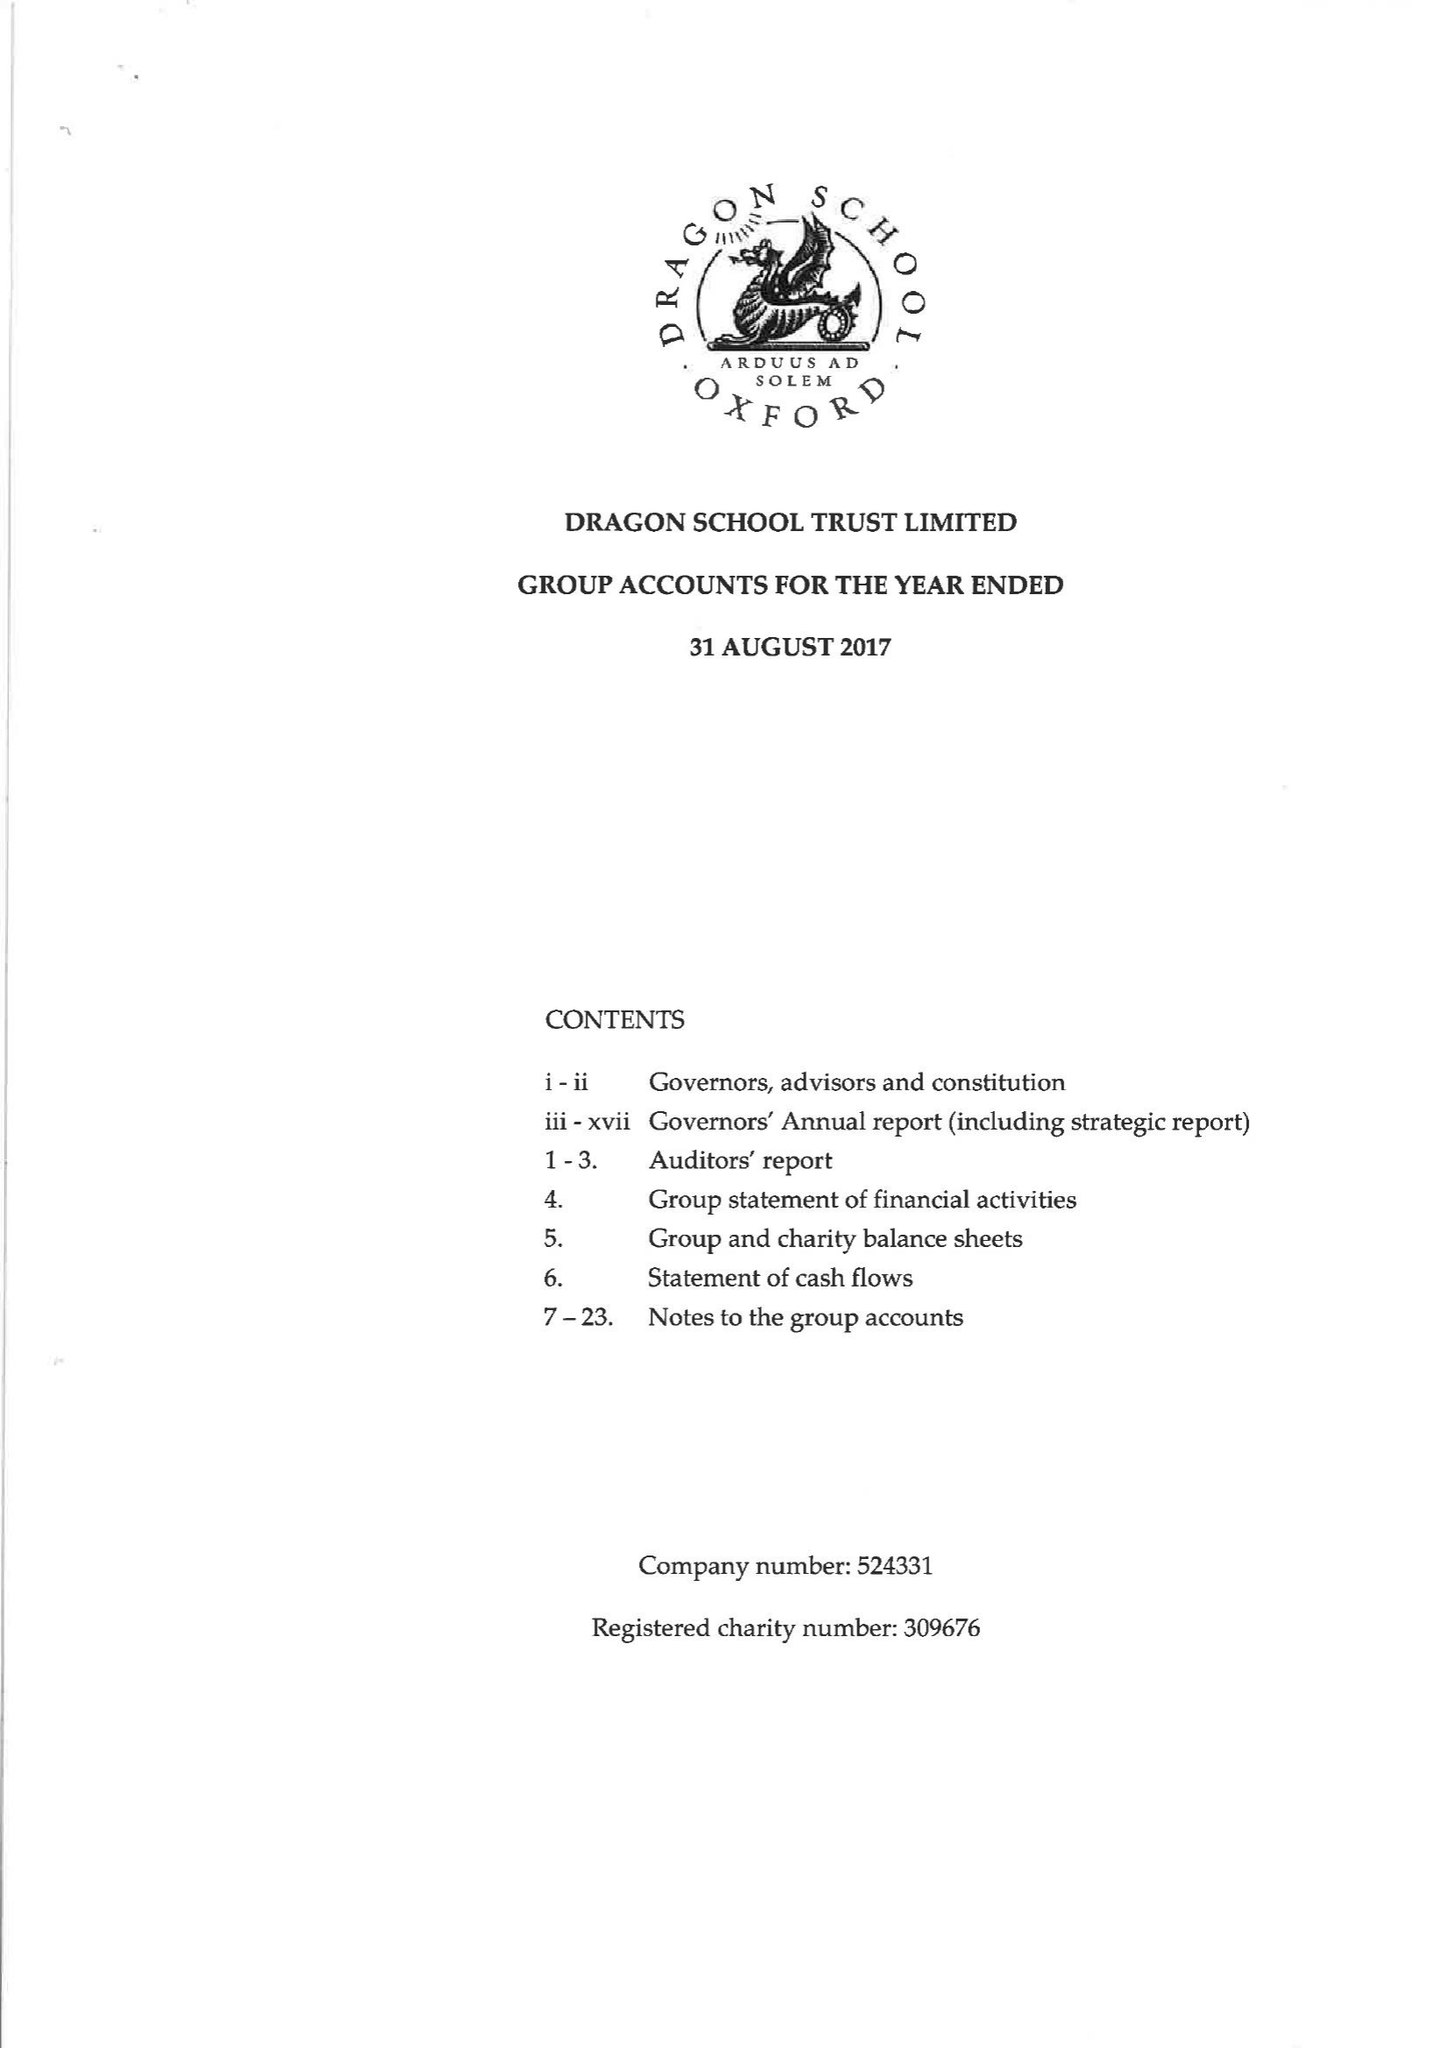What is the value for the report_date?
Answer the question using a single word or phrase. 2017-08-31 